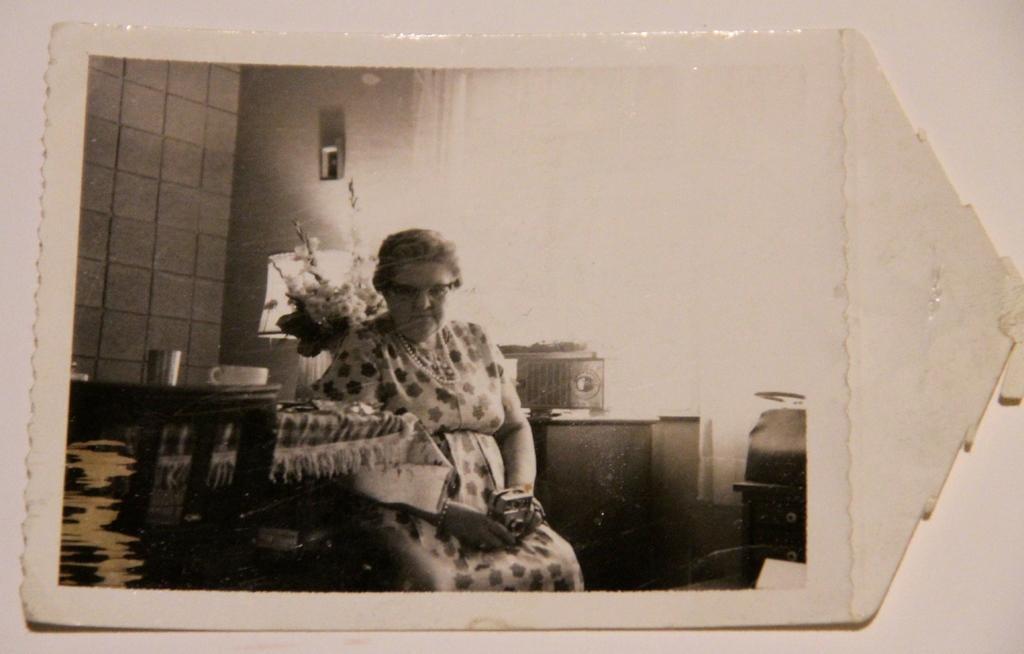Please provide a concise description of this image. In this picture we can see a photo, here we can see a woman is sitting in the middle, on the left side there is a table, we can see a glass and a cup present on the table, in the background there is a wall. 